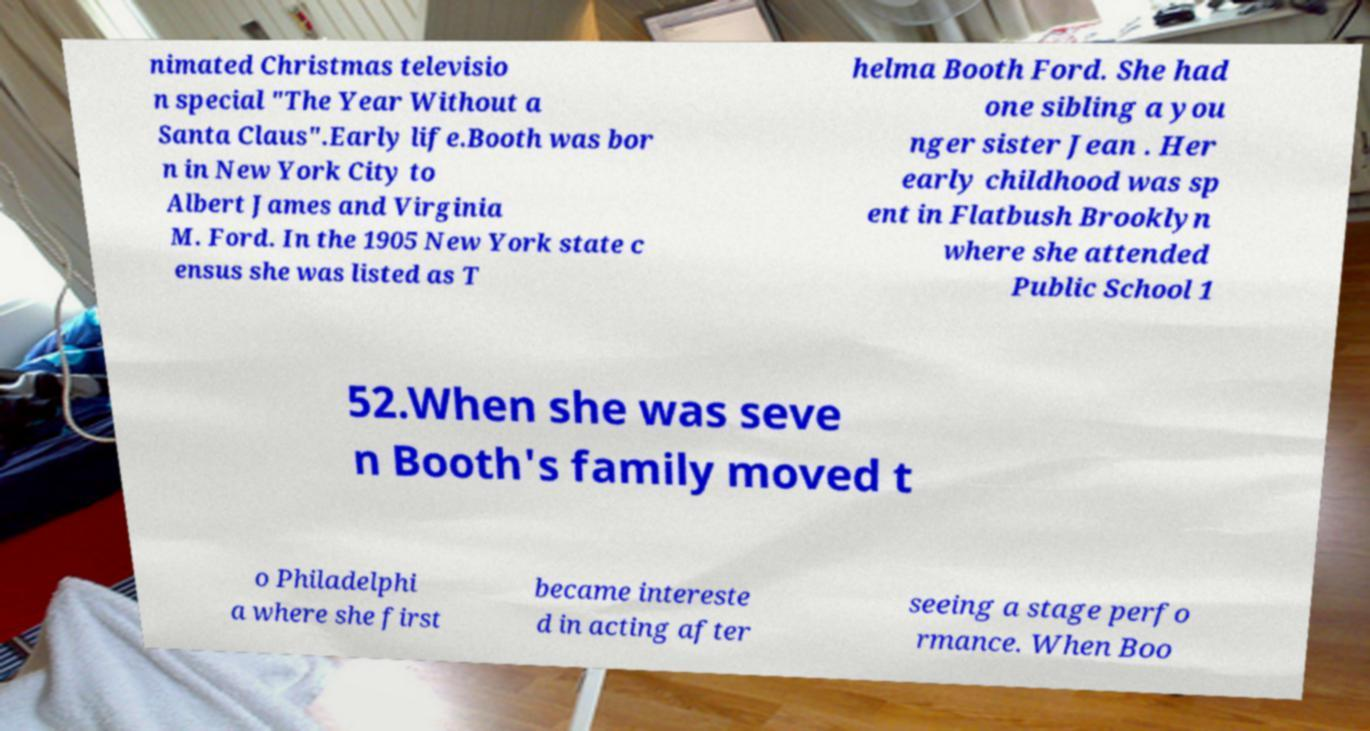Could you assist in decoding the text presented in this image and type it out clearly? nimated Christmas televisio n special "The Year Without a Santa Claus".Early life.Booth was bor n in New York City to Albert James and Virginia M. Ford. In the 1905 New York state c ensus she was listed as T helma Booth Ford. She had one sibling a you nger sister Jean . Her early childhood was sp ent in Flatbush Brooklyn where she attended Public School 1 52.When she was seve n Booth's family moved t o Philadelphi a where she first became intereste d in acting after seeing a stage perfo rmance. When Boo 